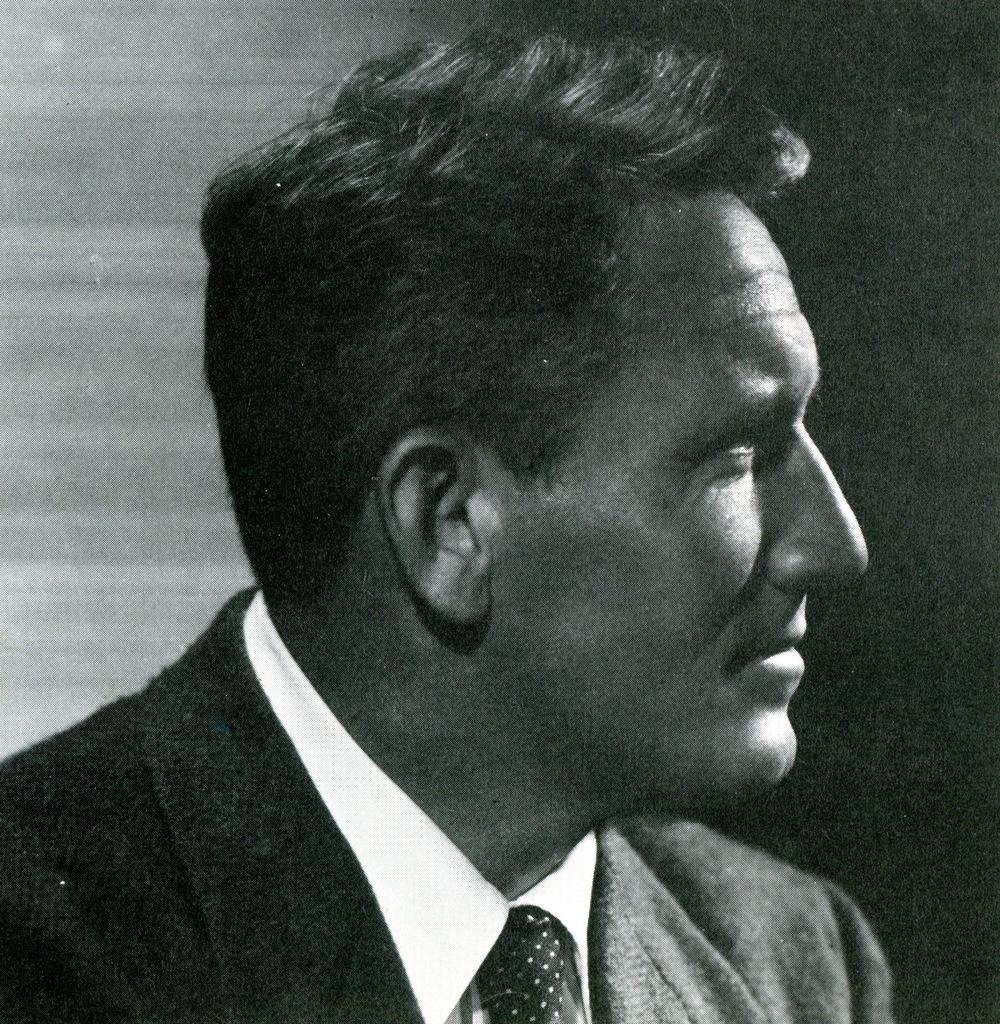What type of picture is in the image? The image contains a black and white picture. Who is depicted in the picture? The picture is of a man. What is the man wearing in the picture? The man is wearing clothes. What is the color of the background in the picture? The background of the picture is dark. How does the man walk in the image? The image is a still picture, so the man is not walking; he is stationary. 